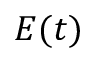<formula> <loc_0><loc_0><loc_500><loc_500>E ( t )</formula> 